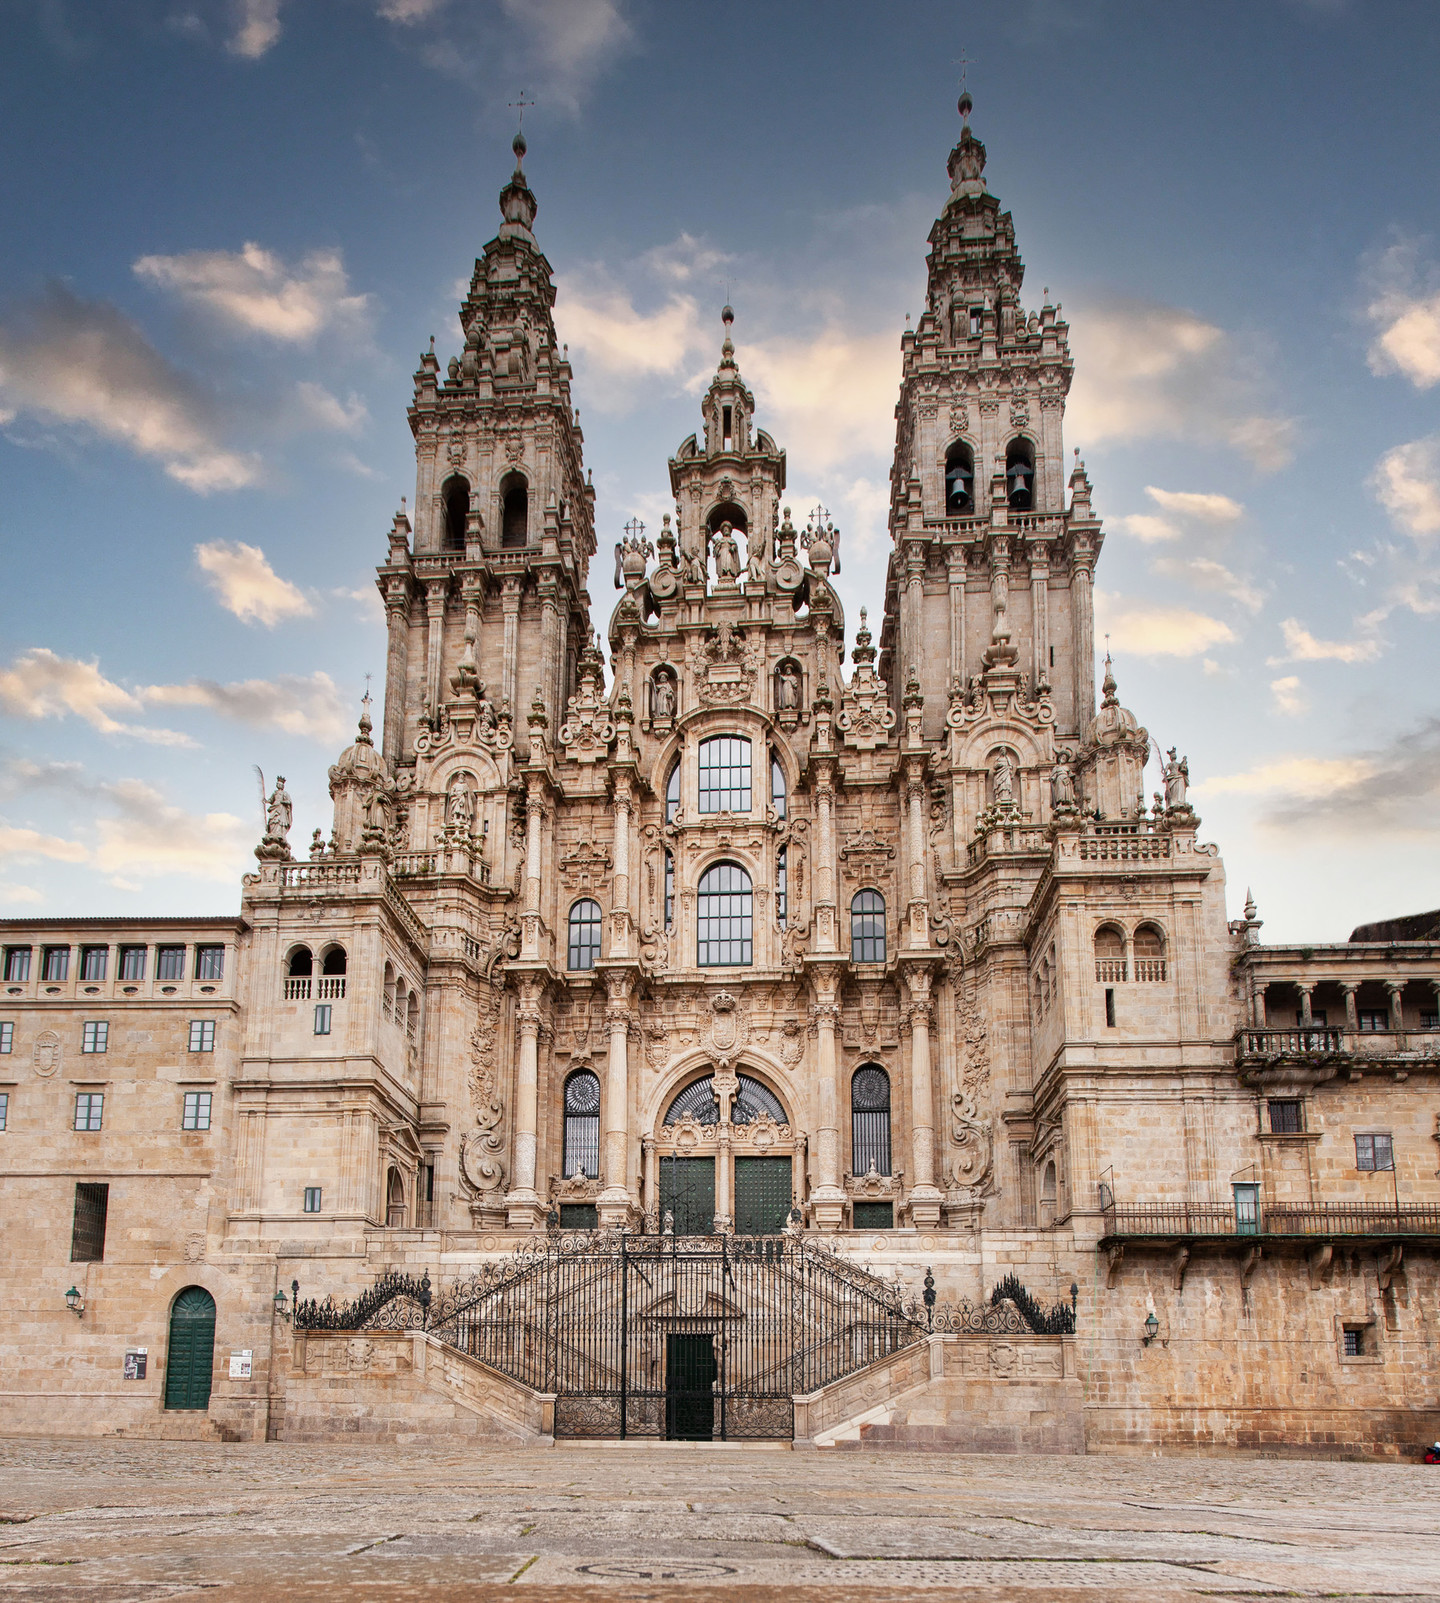What are the key elements in this picture? The image prominently showcases the grandeur and architectural splendor of the Cathedral Santiago De Compostela in Spain. The cathedral is an imposing structure, highlighted by its two towering spires that frame the main entrance, lending a sense of balance and majesty. The facade is rich in intricate details, adorned with numerous statues and elaborate carvings that offer a glimpse into the craftsmanship and artistic dedication imbued in its creation. Captured from a low angle, the photograph emphasizes the cathedral's monumental stature against the background of a serene sky dotted with clouds. The warm, sunlit hues of the cathedral's stone facade contrast strikingly with the blue sky, adding to the overall visual impact and magnificence of the scene. 